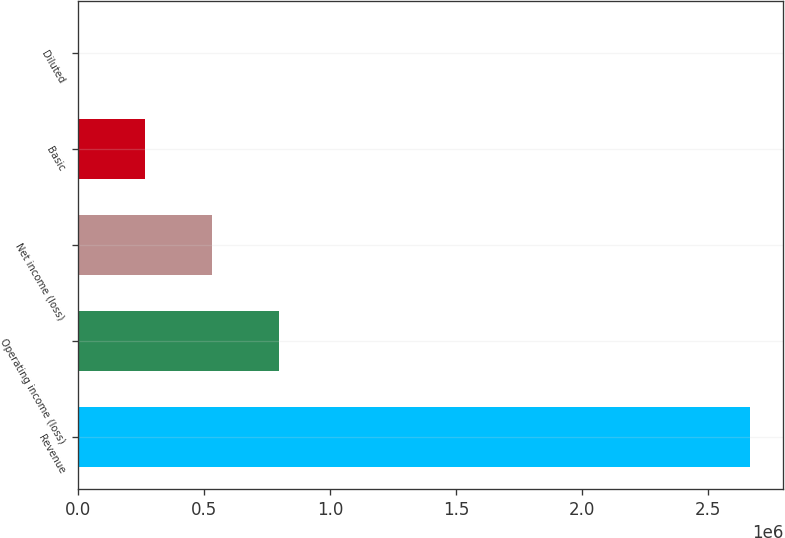Convert chart. <chart><loc_0><loc_0><loc_500><loc_500><bar_chart><fcel>Revenue<fcel>Operating income (loss)<fcel>Net income (loss)<fcel>Basic<fcel>Diluted<nl><fcel>2.66533e+06<fcel>799600<fcel>533067<fcel>266534<fcel>0.94<nl></chart> 